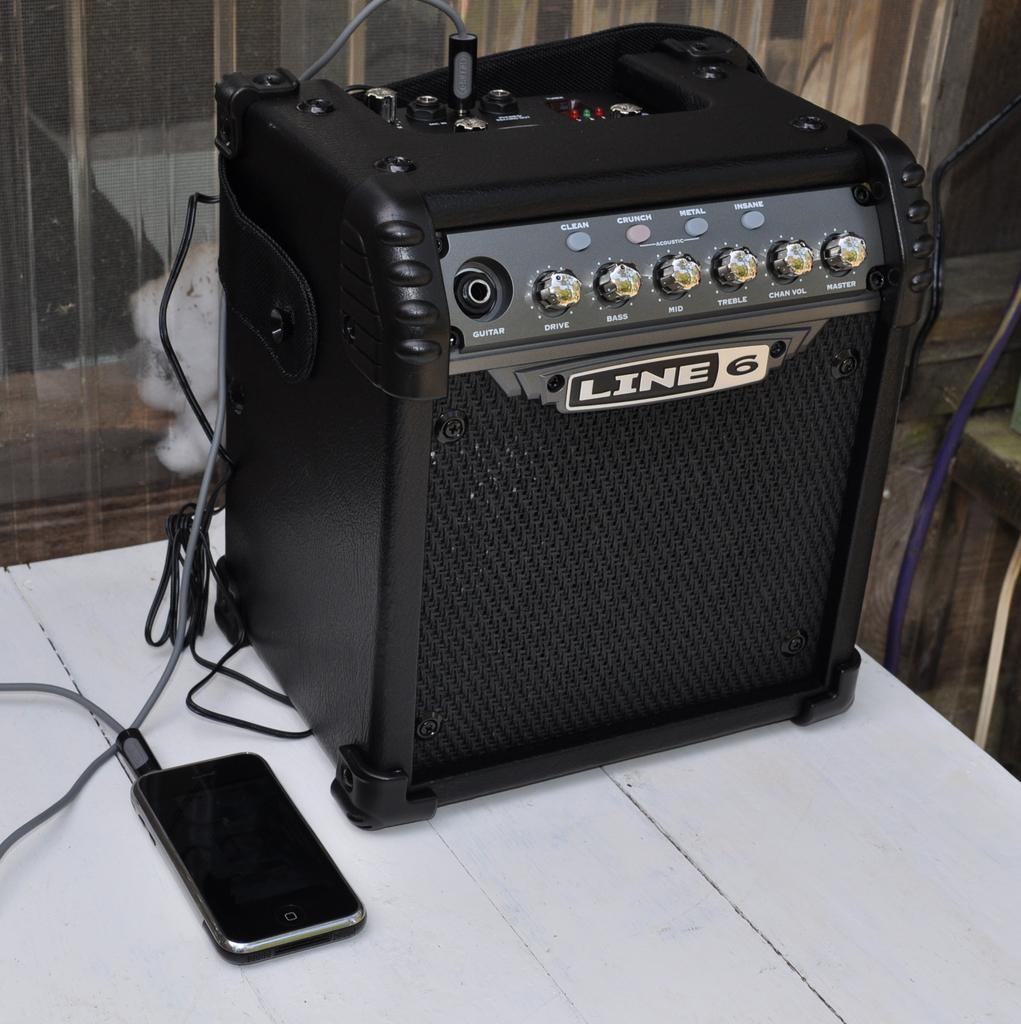<image>
Summarize the visual content of the image. A speaker with clean, crunch and metal options 